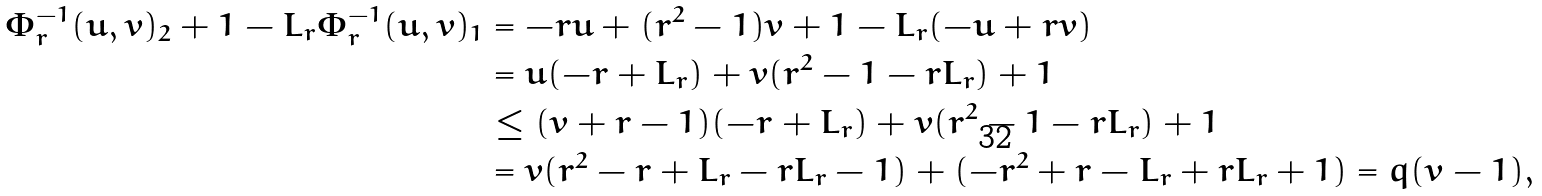Convert formula to latex. <formula><loc_0><loc_0><loc_500><loc_500>\Phi _ { r } ^ { - 1 } ( u , v ) _ { 2 } + 1 - L _ { r } \Phi _ { r } ^ { - 1 } ( u , v ) _ { 1 } & = - r u + ( r ^ { 2 } - 1 ) v + 1 - L _ { r } ( - u + r v ) \\ & = u ( - r + L _ { r } ) + v ( r ^ { 2 } - 1 - r L _ { r } ) + 1 \\ & \leq ( v + r - 1 ) ( - r + L _ { r } ) + v ( r ^ { 2 } - 1 - r L _ { r } ) + 1 \\ & = v ( r ^ { 2 } - r + L _ { r } - r L _ { r } - 1 ) + ( - r ^ { 2 } + r - L _ { r } + r L _ { r } + 1 ) = q ( v - 1 ) ,</formula> 